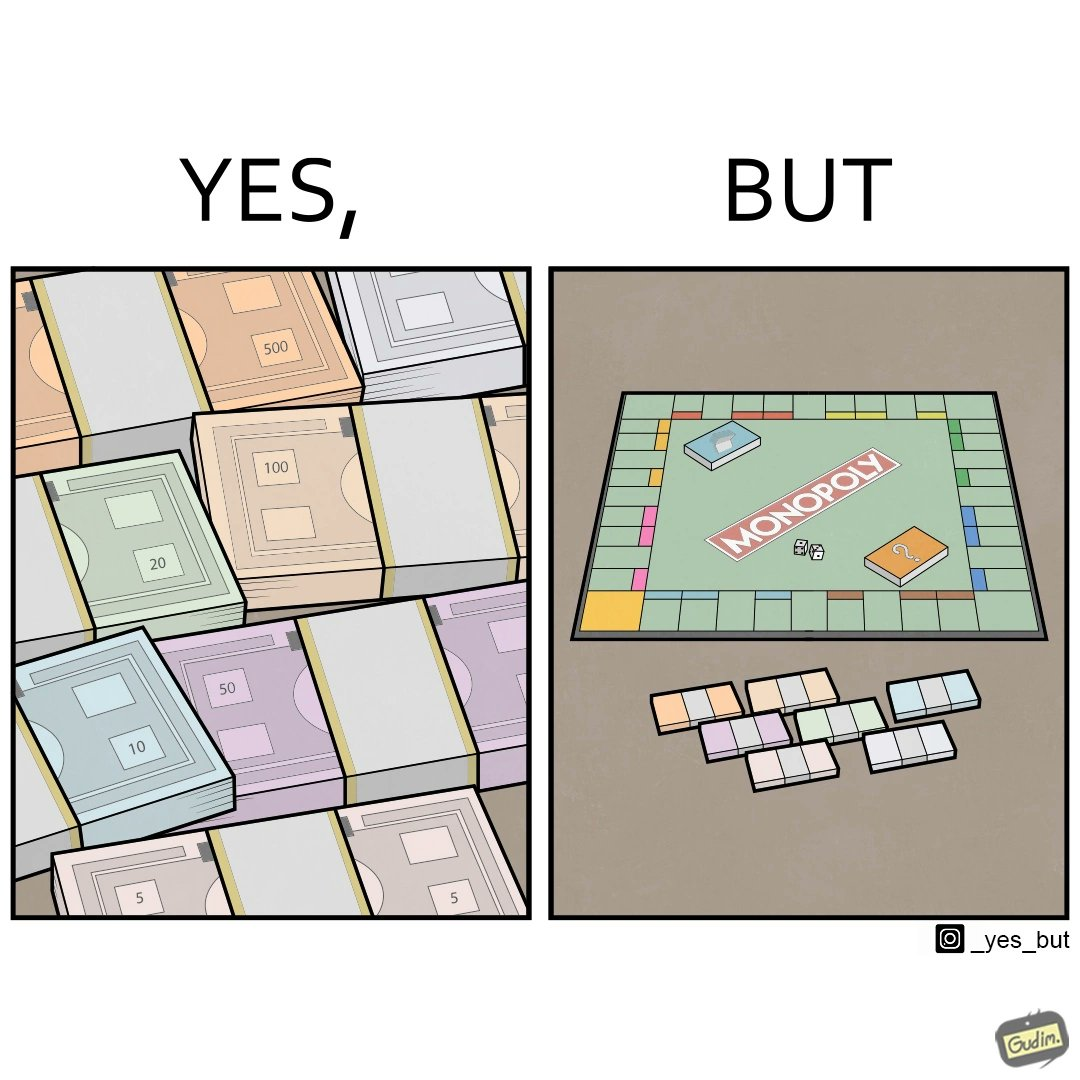What do you see in each half of this image? In the left part of the image: many different color currency notes' bundles In the right part of the image: a board of game monopoly with many different color currency notes' bundles 